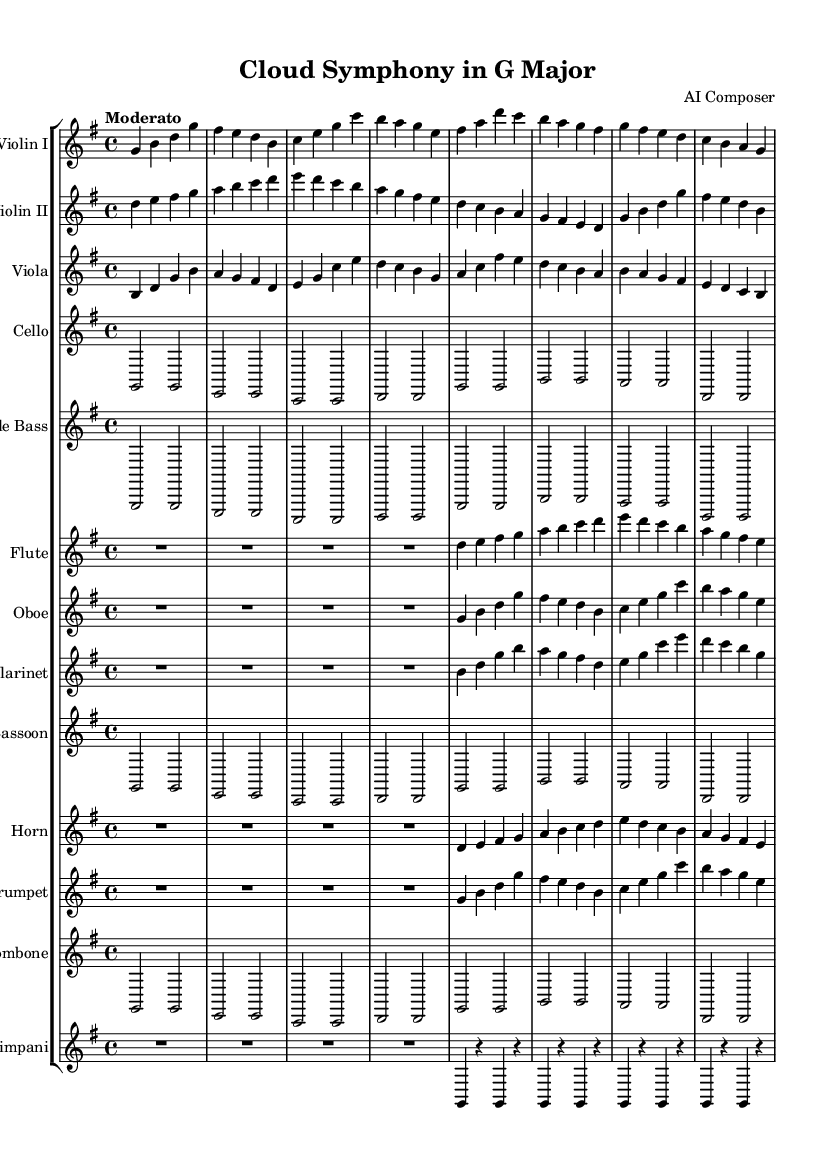What is the key signature of this music? The key signature can be found at the beginning of the score, indicating one sharp which corresponds to the G major key.
Answer: G major What is the time signature of this music? The time signature is located at the start of the score, showing a 4/4 time signature, which means there are four beats per measure.
Answer: 4/4 What is the tempo marking in the score? The tempo marking "Moderato" is specified at the beginning of the score, indicating a moderate pace of the music.
Answer: Moderato How many instruments are being featured in this symphony? To find the number of instruments, we can count the staffs; there are thirteen different instruments listed in the score.
Answer: Thirteen What type of music piece is this? The title at the top of the score indicates that this is a "Symphony," which is a complex orchestral composition.
Answer: Symphony Which instrument plays the melody in this symphony? By examining the different staves and their notes, the Violin I part typically carries the primary melodic line.
Answer: Violin I What notable characteristic can be seen in the timpani part? The timpani part is unique in this piece as it mostly features rests, indicating that the instrument is used sparingly.
Answer: Rests 